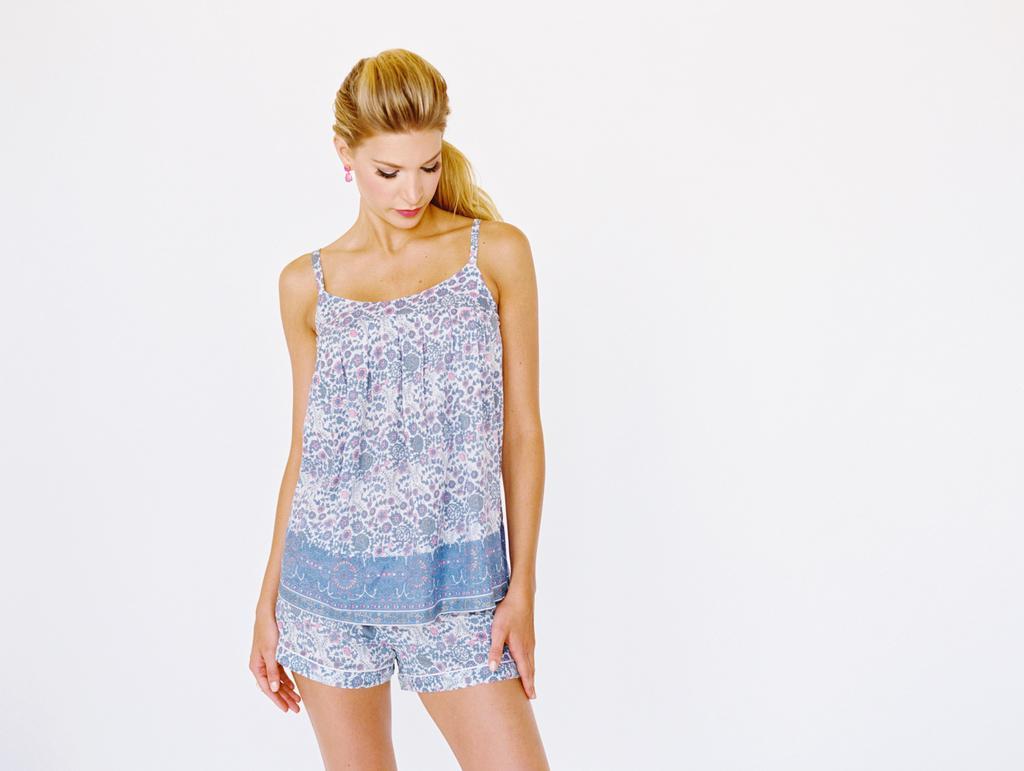Please provide a concise description of this image. In this picture there is a woman who is wearing blue dress. She is standing near to the wall. 